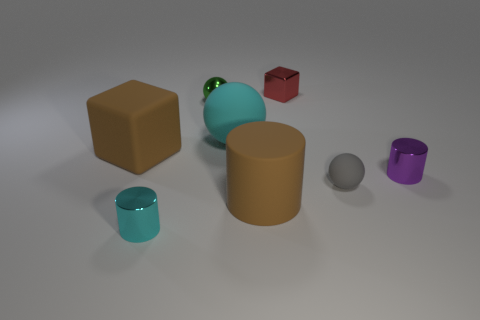Are the large brown cylinder and the purple cylinder made of the same material?
Provide a short and direct response. No. Is the size of the metal cylinder that is in front of the purple shiny cylinder the same as the shiny cylinder on the right side of the gray object?
Provide a succinct answer. Yes. Are there fewer blue cylinders than metallic spheres?
Give a very brief answer. Yes. What number of metallic things are cyan things or small red blocks?
Provide a succinct answer. 2. There is a ball that is left of the big ball; is there a gray object right of it?
Ensure brevity in your answer.  Yes. Do the block that is in front of the small shiny block and the big sphere have the same material?
Provide a succinct answer. Yes. What number of other things are the same color as the big cylinder?
Give a very brief answer. 1. Do the big matte ball and the rubber cylinder have the same color?
Provide a succinct answer. No. How big is the brown rubber thing on the right side of the large brown rubber thing that is on the left side of the tiny green sphere?
Keep it short and to the point. Large. Is the material of the brown thing behind the small purple metallic thing the same as the large brown thing that is on the right side of the small green sphere?
Make the answer very short. Yes. 